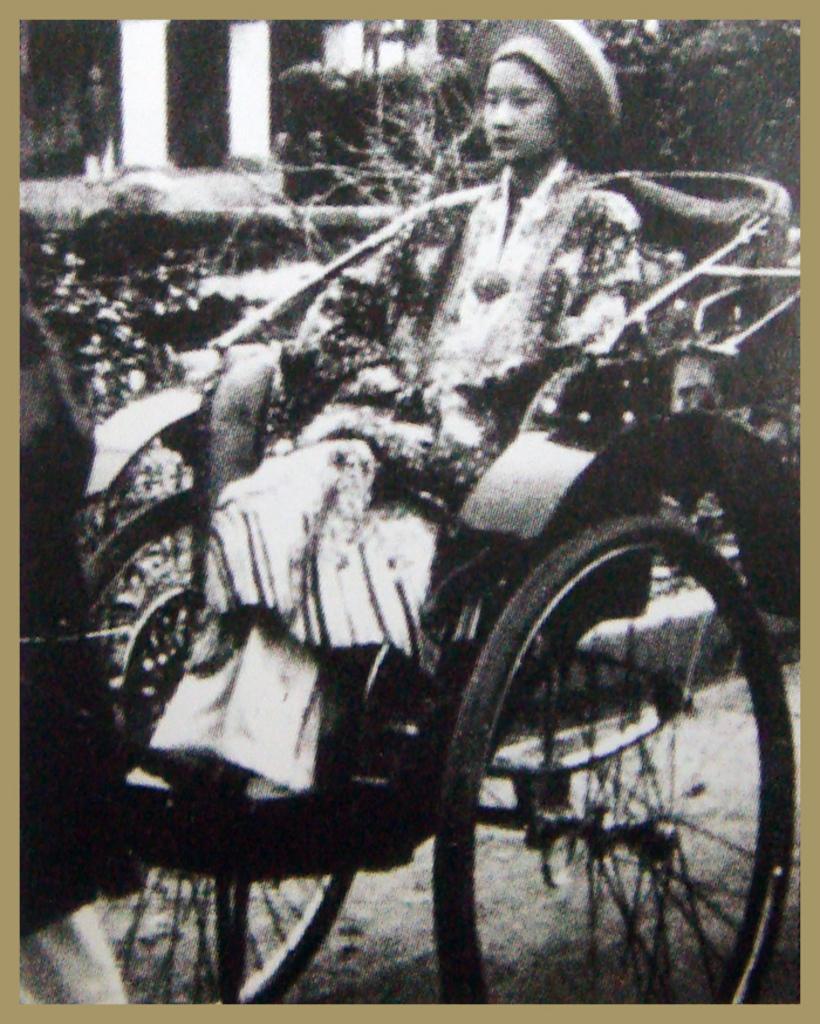Could you give a brief overview of what you see in this image? In this image we can see a person sitting on the rickshaw, there are few trees and a person standing near the pillar in the background. 